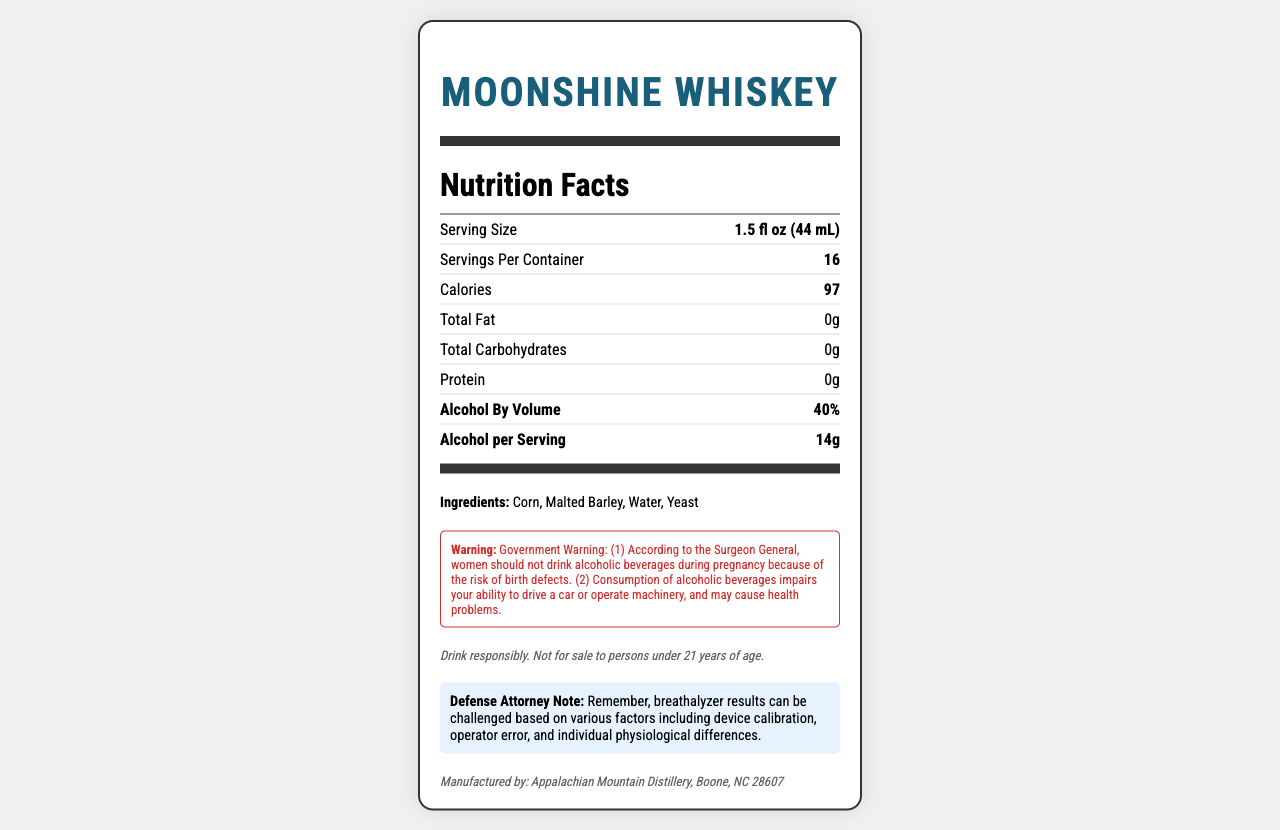who manufactures Moonshine Whiskey? The manufacturer's information is provided at the bottom of the document under the disclaimer section.
Answer: Appalachian Mountain Distillery, Boone, NC 28607 what is the proof level of Moonshine Whiskey? The proof level is stated in the document as "proofLevel": "80 proof".
Answer: 80 proof how many servings are in one container? The servings per container are mentioned under servingsPerContainer: 16.
Answer: 16 how many calories are in one serving? The document lists the calories per serving as 97 under the nutrition facts section.
Answer: 97 calories what ingredients are used in Moonshine Whiskey? The ingredients are listed under the ingredients section in the document.
Answer: Corn, Malted Barley, Water, Yeast what is the alcohol by volume (ABV) in Moonshine Whiskey? The alcohol by volume is underlined in the nutrition facts section as "alcoholByVolume": "40%".
Answer: 40% does Moonshine Whiskey contain any allergens? The document specifies that it contains barley under the allergens section.
Answer: Yes what warning is provided about the consumption of Moonshine Whiskey? This information is included in the warningStatement section.
Answer: Women should not drink during pregnancy, it impairs ability to drive or operate machinery and may cause health problems. A standard drink of Moonshine Whiskey is metabolized in approximately: A. 30 minutes B. 1 hour C. 2 hours D. 3 hours The document describes that the metabolization rate is approximately 1 standard drink per hour.
Answer: B how many grams of alcohol are in one serving? This information is provided in the nutrition facts section under "alcoholGramsPerServing": 14.
Answer: 14 grams which nutritional components are present in Moonshine Whiskey? A. Carbs and Protein B. Fat and Carbs C. Only Protein D. None of the above The document specifies that there are no carbs, fat, or protein in the product.
Answer: D was there any mention of Moonshine Whiskey having sugars? The document does not mention any sugars under the nutrition or ingredients sections.
Answer: No describe the overall content of the document. The document combines nutritional and safety information with specific details about breathalyzer considerations and defense attorney insights into challenging DUI cases.
Answer: The document provides comprehensive information about Moonshine Whiskey, including nutritional facts, alcohol content, ingredients, warnings, legal disclaimers, and manufacturer details. It also includes a special note about how breathalyzer results may be challenged. can the exact amount of water used be determined? The document lists "water" as an ingredient but does not provide the exact amount used.
Answer: Cannot be determined how many calories come from protein per serving? The document specifies that there are no calories from protein as indicated under "caloriesFromProtein": 0.
Answer: 0 calories 